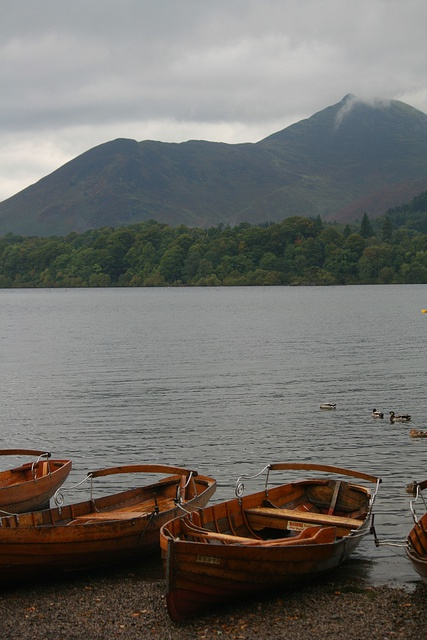Describe the objects in this image and their specific colors. I can see boat in darkgray, black, maroon, and gray tones, boat in darkgray, black, maroon, gray, and brown tones, boat in darkgray, maroon, black, and gray tones, boat in darkgray, black, maroon, and gray tones, and bird in darkgray, black, and gray tones in this image. 